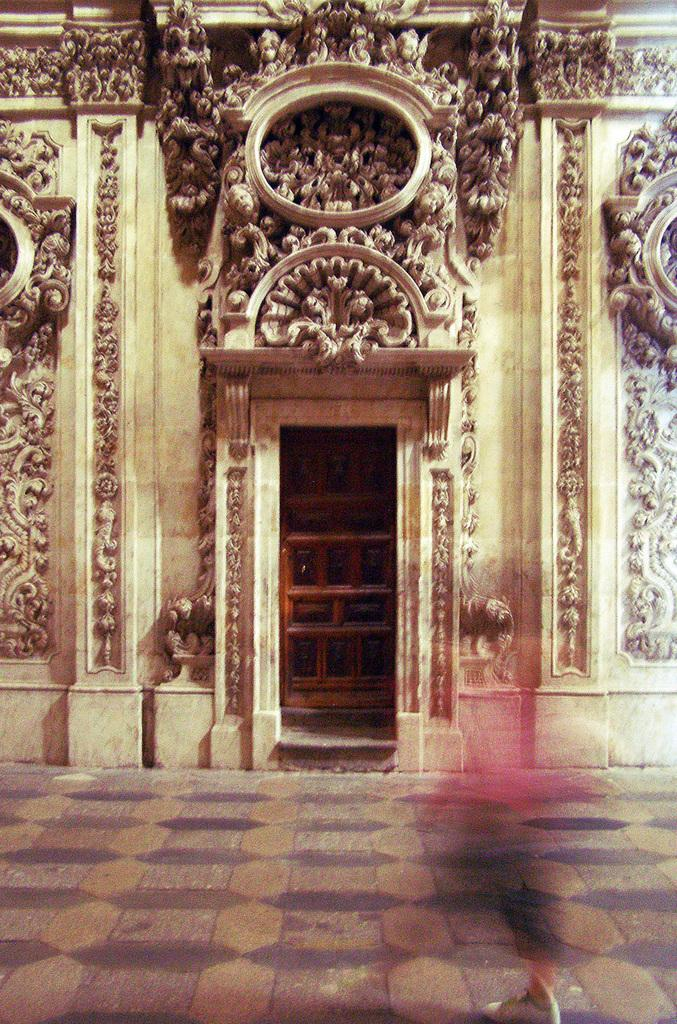What is the main structure in the image? There is a building in the image. What part of the building can be seen in the image? There is a door visible in the image. What surface is visible beneath the door? There is a floor visible in the image. Where is the hose connected to the building in the image? There is no hose connected to the building in the image. What type of credit can be seen on the door in the image? There is no credit or label visible on the door in the image. 